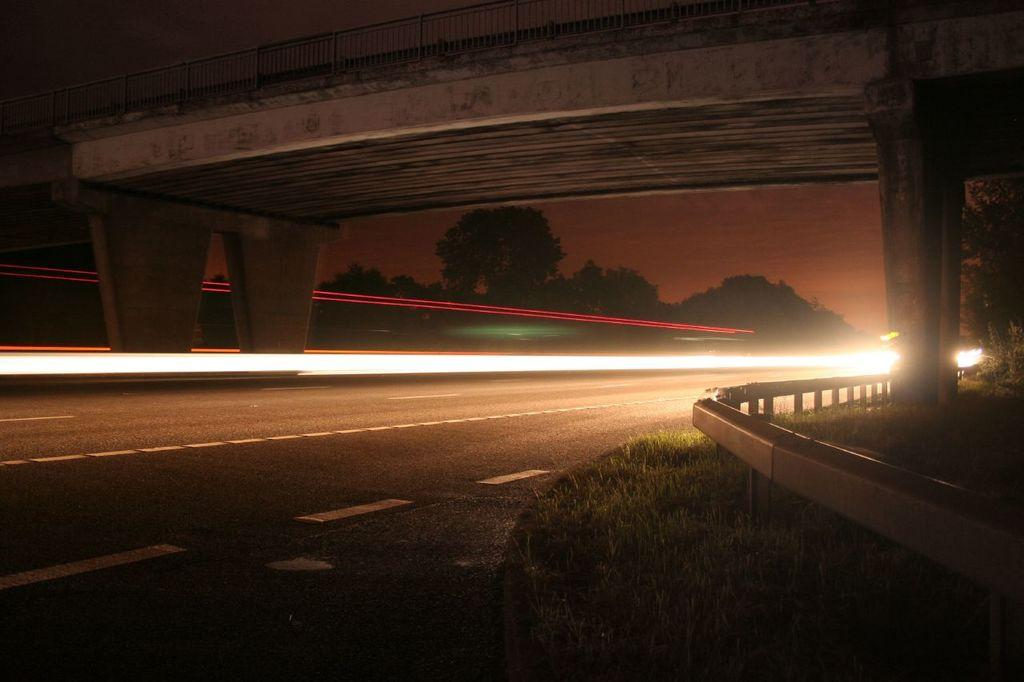What type of pathway can be seen in the image? There is a road in the image. What type of vegetation is present in the image? Grass is present in the image. What type of barrier can be seen in the image? There is a fence in the image. What type of structure is present in the image that allows people or vehicles to cross over a body of water or obstacle? There is a bridge in the image. What type of natural feature is visible in the image? Trees are visible in the image. What type of illumination is present in the image? Lights are present in the image. What can be seen in the background of the image? The sky is visible in the background of the image. What rule is being enforced by the spot of light in the image? There is no spot of light in the image, and therefore no rule is being enforced. How does the image depict the characters saying good-bye to each other? There are no characters present in the image, and therefore no good-byes are depicted. 